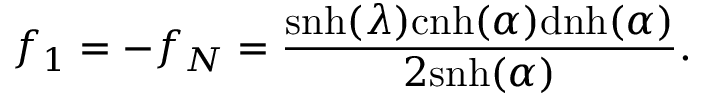Convert formula to latex. <formula><loc_0><loc_0><loc_500><loc_500>f _ { 1 } = - f _ { N } = \frac { s n h ( \lambda ) c n h ( \alpha ) d n h ( \alpha ) } { 2 s n h ( \alpha ) } .</formula> 